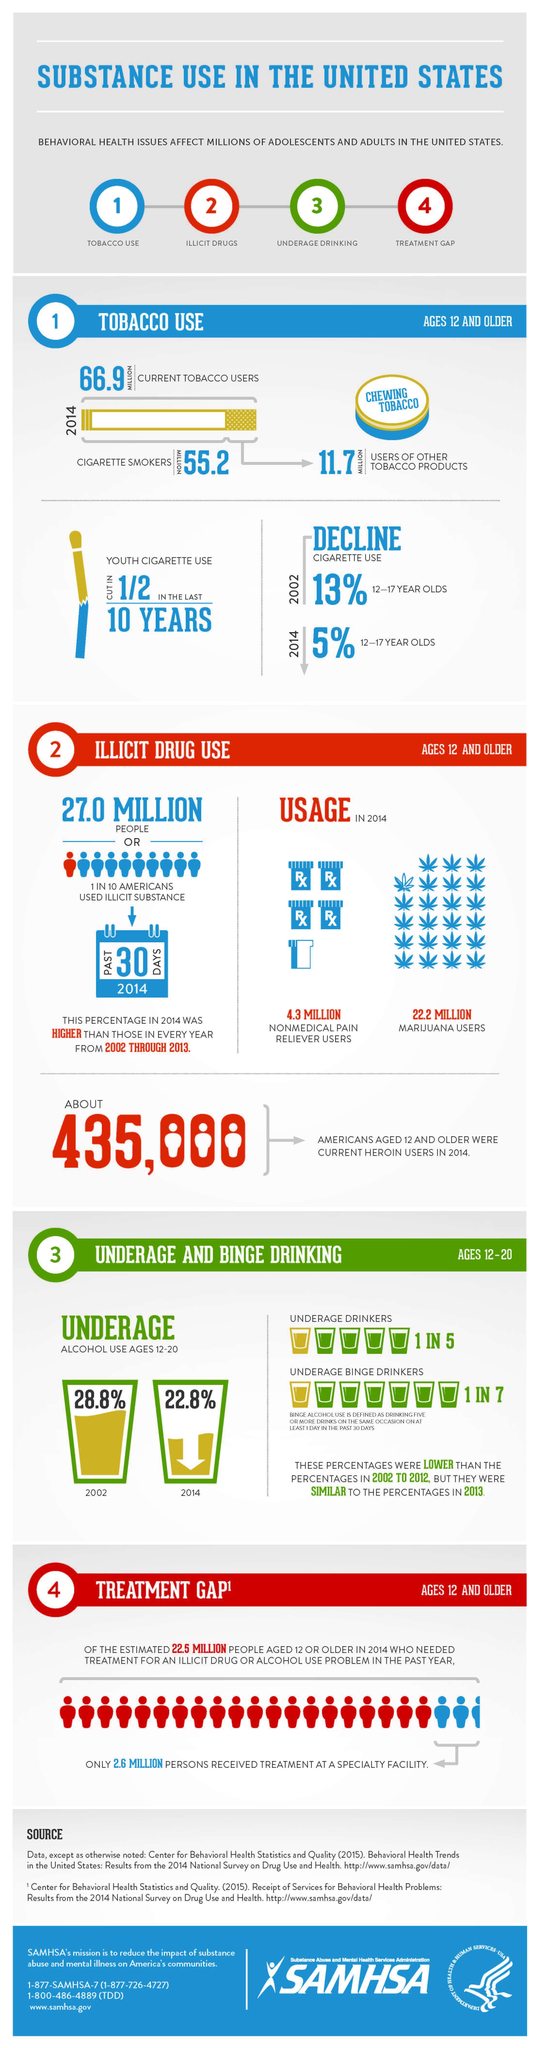How many behavioral health issues affect adolescents and adults in the US?
Answer the question with a short phrase. 4 What is the total illicit drug usage through non medical pain reliever drugs and Marijuana? 26.5 Million What is the percentage decrease in alcohol use between the year 2002 and 2014? 6% What is the decline in cigarette use between 2002 to 2014 ? 8% 